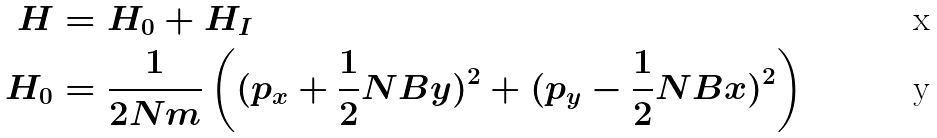Convert formula to latex. <formula><loc_0><loc_0><loc_500><loc_500>H & = H _ { 0 } + H _ { I } \\ H _ { 0 } & = \frac { 1 } { 2 N m } \left ( ( p _ { x } + \frac { 1 } { 2 } N B y ) ^ { 2 } + ( p _ { y } - \frac { 1 } { 2 } N B x ) ^ { 2 } \right )</formula> 